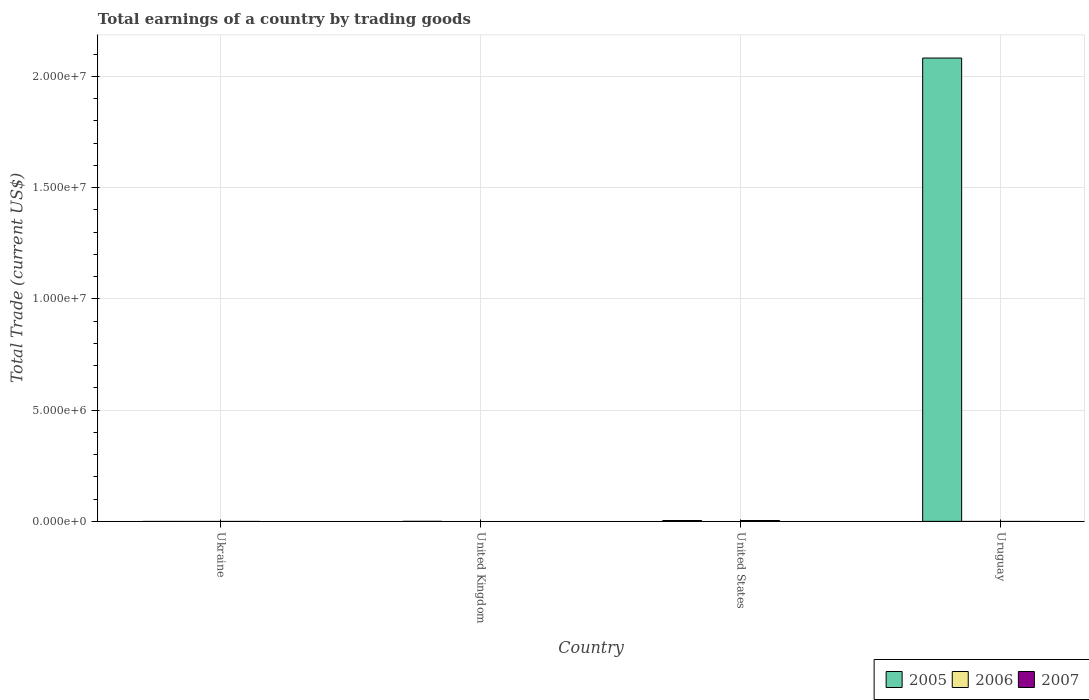Are the number of bars per tick equal to the number of legend labels?
Your response must be concise. No. What is the label of the 4th group of bars from the left?
Offer a terse response. Uruguay. What is the total earnings in 2007 in United Kingdom?
Provide a short and direct response. 0. Across all countries, what is the maximum total earnings in 2005?
Provide a succinct answer. 2.08e+07. Across all countries, what is the minimum total earnings in 2007?
Make the answer very short. 0. In which country was the total earnings in 2005 maximum?
Your response must be concise. Uruguay. What is the total total earnings in 2005 in the graph?
Offer a very short reply. 2.08e+07. What is the average total earnings in 2005 per country?
Your answer should be very brief. 5.20e+06. In how many countries, is the total earnings in 2005 greater than the average total earnings in 2005 taken over all countries?
Offer a terse response. 1. Is it the case that in every country, the sum of the total earnings in 2007 and total earnings in 2006 is greater than the total earnings in 2005?
Your answer should be compact. No. How many bars are there?
Offer a very short reply. 1. Where does the legend appear in the graph?
Provide a succinct answer. Bottom right. How many legend labels are there?
Your response must be concise. 3. What is the title of the graph?
Ensure brevity in your answer.  Total earnings of a country by trading goods. What is the label or title of the Y-axis?
Give a very brief answer. Total Trade (current US$). What is the Total Trade (current US$) in 2005 in Ukraine?
Give a very brief answer. 0. What is the Total Trade (current US$) of 2006 in Ukraine?
Keep it short and to the point. 0. What is the Total Trade (current US$) in 2005 in Uruguay?
Keep it short and to the point. 2.08e+07. Across all countries, what is the maximum Total Trade (current US$) in 2005?
Your answer should be compact. 2.08e+07. What is the total Total Trade (current US$) of 2005 in the graph?
Provide a short and direct response. 2.08e+07. What is the total Total Trade (current US$) of 2006 in the graph?
Ensure brevity in your answer.  0. What is the average Total Trade (current US$) of 2005 per country?
Offer a terse response. 5.20e+06. What is the average Total Trade (current US$) in 2006 per country?
Provide a succinct answer. 0. What is the average Total Trade (current US$) of 2007 per country?
Offer a very short reply. 0. What is the difference between the highest and the lowest Total Trade (current US$) in 2005?
Offer a terse response. 2.08e+07. 